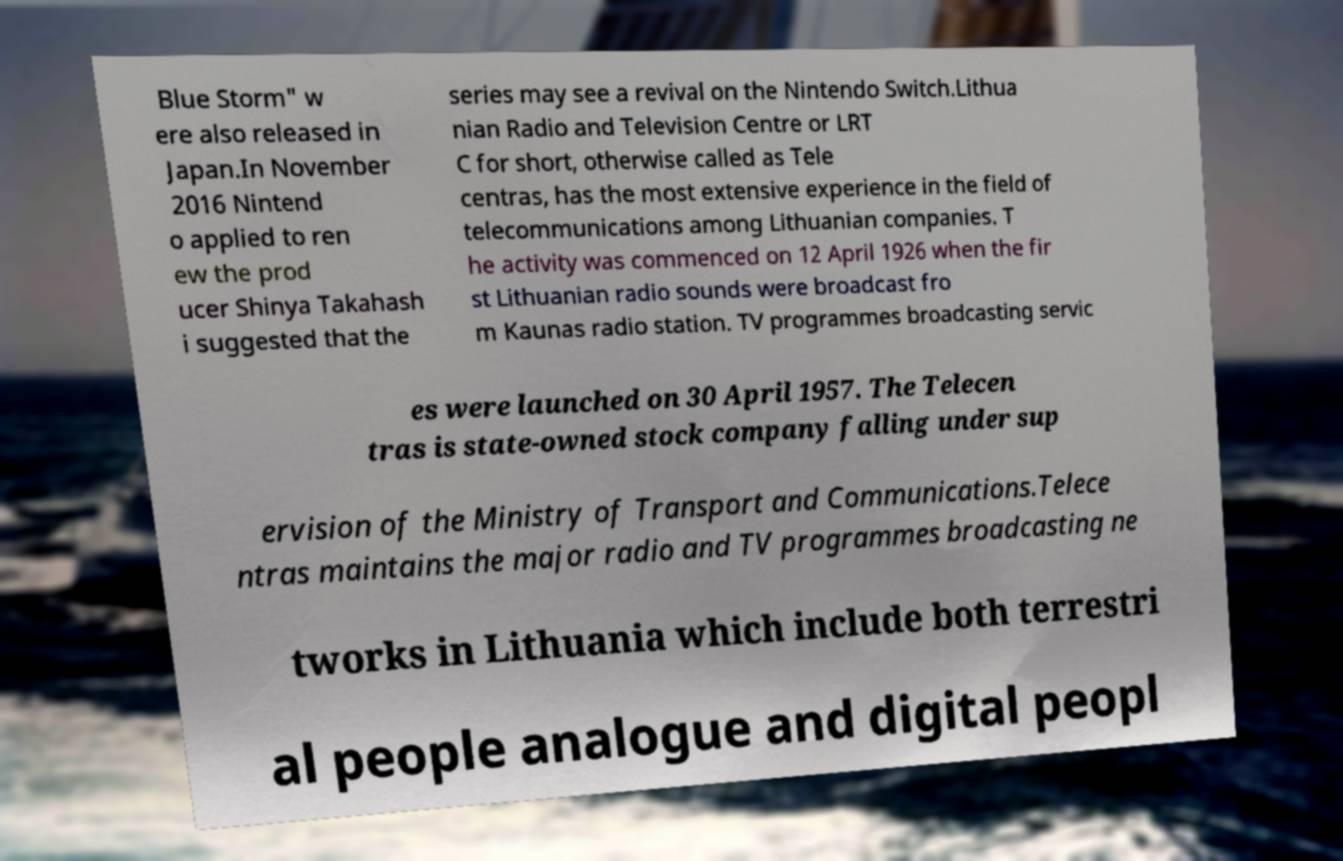For documentation purposes, I need the text within this image transcribed. Could you provide that? Blue Storm" w ere also released in Japan.In November 2016 Nintend o applied to ren ew the prod ucer Shinya Takahash i suggested that the series may see a revival on the Nintendo Switch.Lithua nian Radio and Television Centre or LRT C for short, otherwise called as Tele centras, has the most extensive experience in the field of telecommunications among Lithuanian companies. T he activity was commenced on 12 April 1926 when the fir st Lithuanian radio sounds were broadcast fro m Kaunas radio station. TV programmes broadcasting servic es were launched on 30 April 1957. The Telecen tras is state-owned stock company falling under sup ervision of the Ministry of Transport and Communications.Telece ntras maintains the major radio and TV programmes broadcasting ne tworks in Lithuania which include both terrestri al people analogue and digital peopl 